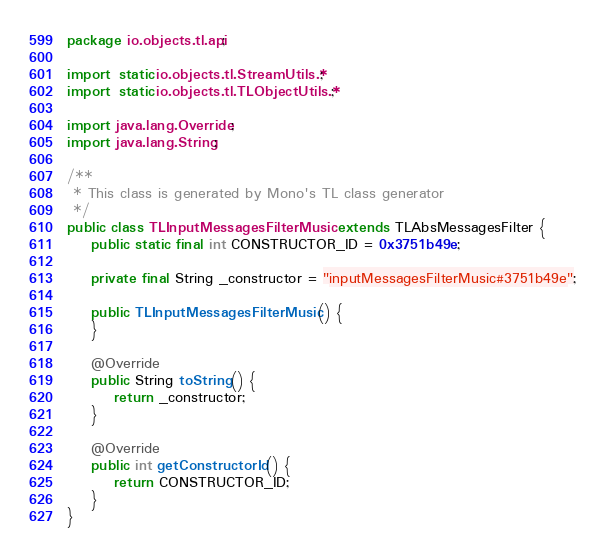<code> <loc_0><loc_0><loc_500><loc_500><_Java_>package io.objects.tl.api;

import static io.objects.tl.StreamUtils.*;
import static io.objects.tl.TLObjectUtils.*;

import java.lang.Override;
import java.lang.String;

/**
 * This class is generated by Mono's TL class generator
 */
public class TLInputMessagesFilterMusic extends TLAbsMessagesFilter {
    public static final int CONSTRUCTOR_ID = 0x3751b49e;

    private final String _constructor = "inputMessagesFilterMusic#3751b49e";

    public TLInputMessagesFilterMusic() {
    }

    @Override
    public String toString() {
        return _constructor;
    }

    @Override
    public int getConstructorId() {
        return CONSTRUCTOR_ID;
    }
}
</code> 